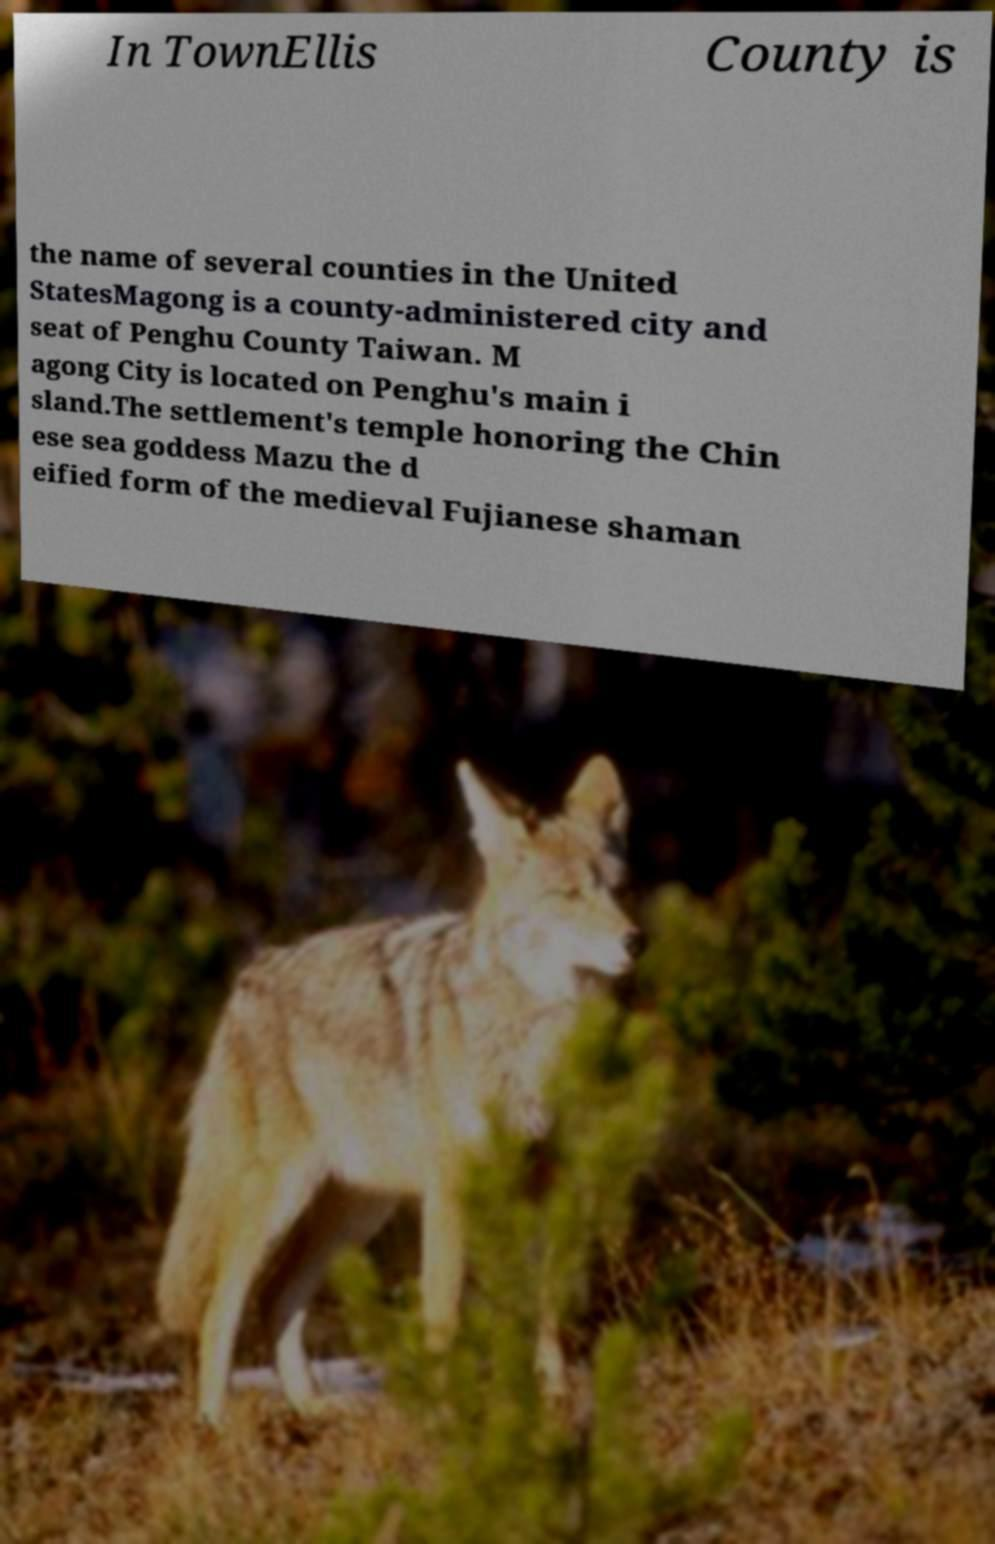Could you extract and type out the text from this image? In TownEllis County is the name of several counties in the United StatesMagong is a county-administered city and seat of Penghu County Taiwan. M agong City is located on Penghu's main i sland.The settlement's temple honoring the Chin ese sea goddess Mazu the d eified form of the medieval Fujianese shaman 